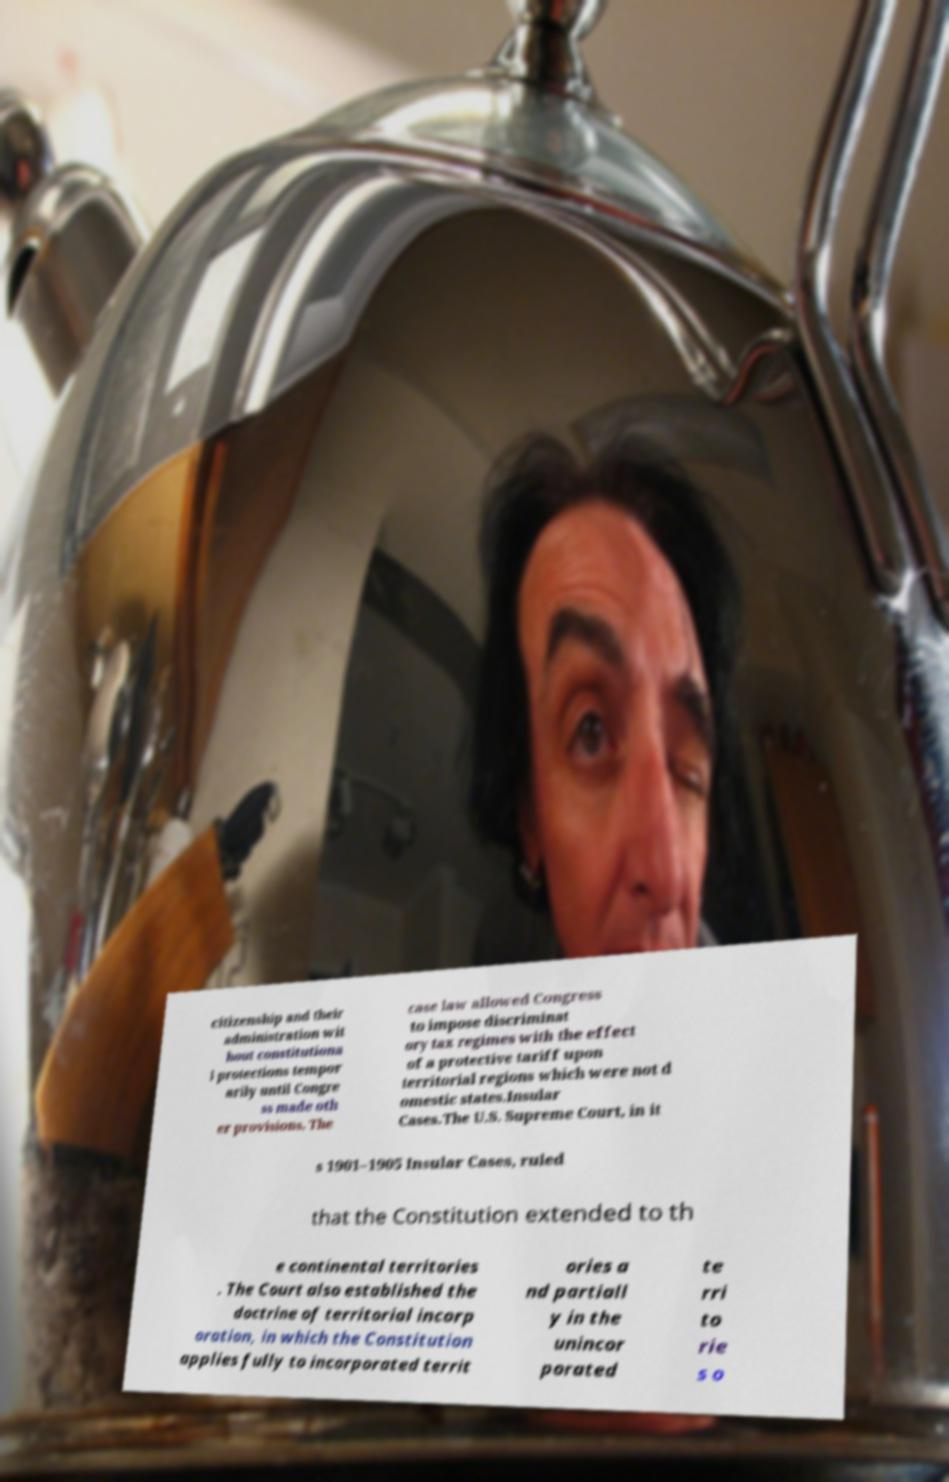There's text embedded in this image that I need extracted. Can you transcribe it verbatim? citizenship and their administration wit hout constitutiona l protections tempor arily until Congre ss made oth er provisions. The case law allowed Congress to impose discriminat ory tax regimes with the effect of a protective tariff upon territorial regions which were not d omestic states.Insular Cases.The U.S. Supreme Court, in it s 1901–1905 Insular Cases, ruled that the Constitution extended to th e continental territories . The Court also established the doctrine of territorial incorp oration, in which the Constitution applies fully to incorporated territ ories a nd partiall y in the unincor porated te rri to rie s o 